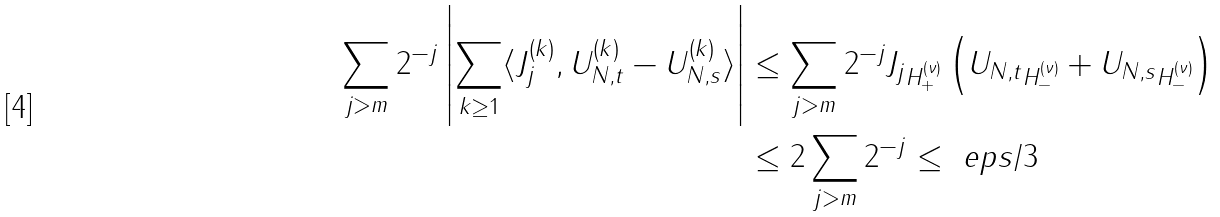Convert formula to latex. <formula><loc_0><loc_0><loc_500><loc_500>\sum _ { j > m } 2 ^ { - j } \left | \sum _ { k \geq 1 } \langle J _ { j } ^ { ( k ) } , U _ { N , t } ^ { ( k ) } - U _ { N , s } ^ { ( k ) } \rangle \right | & \leq \sum _ { j > m } 2 ^ { - j } \| J _ { j } \| _ { H _ { + } ^ { ( \nu ) } } \left ( \| U _ { N , t } \| _ { H _ { - } ^ { ( \nu ) } } + \| U _ { N , s } \| _ { H _ { - } ^ { ( \nu ) } } \right ) \\ & \leq 2 \sum _ { j > m } 2 ^ { - j } \leq \ e p s / 3</formula> 